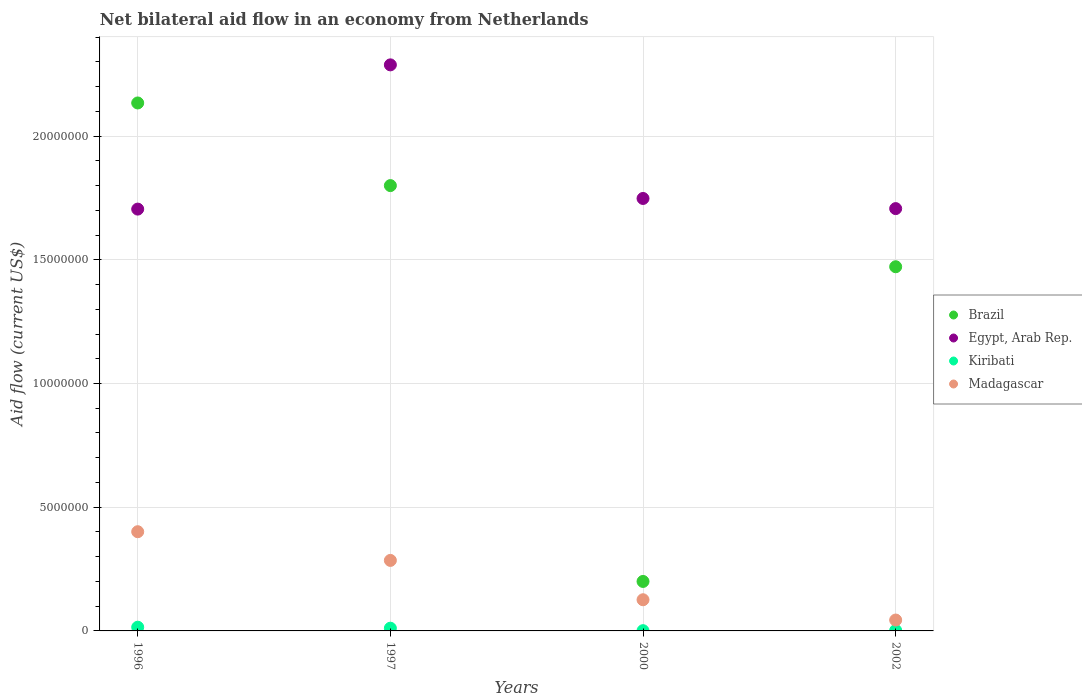How many different coloured dotlines are there?
Offer a terse response. 4. Is the number of dotlines equal to the number of legend labels?
Make the answer very short. Yes. What is the net bilateral aid flow in Madagascar in 1996?
Your response must be concise. 4.01e+06. Across all years, what is the minimum net bilateral aid flow in Egypt, Arab Rep.?
Give a very brief answer. 1.70e+07. In which year was the net bilateral aid flow in Kiribati maximum?
Your response must be concise. 1996. In which year was the net bilateral aid flow in Kiribati minimum?
Offer a very short reply. 2000. What is the total net bilateral aid flow in Egypt, Arab Rep. in the graph?
Give a very brief answer. 7.45e+07. What is the difference between the net bilateral aid flow in Brazil in 2000 and that in 2002?
Provide a short and direct response. -1.27e+07. What is the difference between the net bilateral aid flow in Egypt, Arab Rep. in 2002 and the net bilateral aid flow in Kiribati in 1997?
Offer a very short reply. 1.70e+07. What is the average net bilateral aid flow in Madagascar per year?
Your answer should be compact. 2.14e+06. In the year 1997, what is the difference between the net bilateral aid flow in Madagascar and net bilateral aid flow in Kiribati?
Provide a short and direct response. 2.74e+06. What is the ratio of the net bilateral aid flow in Madagascar in 1997 to that in 2000?
Give a very brief answer. 2.26. Is the net bilateral aid flow in Madagascar in 1996 less than that in 1997?
Provide a succinct answer. No. Is the difference between the net bilateral aid flow in Madagascar in 1997 and 2002 greater than the difference between the net bilateral aid flow in Kiribati in 1997 and 2002?
Provide a short and direct response. Yes. What is the difference between the highest and the second highest net bilateral aid flow in Egypt, Arab Rep.?
Provide a succinct answer. 5.40e+06. What is the difference between the highest and the lowest net bilateral aid flow in Brazil?
Provide a short and direct response. 1.93e+07. Is it the case that in every year, the sum of the net bilateral aid flow in Egypt, Arab Rep. and net bilateral aid flow in Brazil  is greater than the sum of net bilateral aid flow in Madagascar and net bilateral aid flow in Kiribati?
Keep it short and to the point. Yes. Is it the case that in every year, the sum of the net bilateral aid flow in Madagascar and net bilateral aid flow in Egypt, Arab Rep.  is greater than the net bilateral aid flow in Kiribati?
Your answer should be compact. Yes. Does the net bilateral aid flow in Brazil monotonically increase over the years?
Your answer should be compact. No. Is the net bilateral aid flow in Kiribati strictly greater than the net bilateral aid flow in Brazil over the years?
Provide a succinct answer. No. Is the net bilateral aid flow in Egypt, Arab Rep. strictly less than the net bilateral aid flow in Brazil over the years?
Ensure brevity in your answer.  No. What is the difference between two consecutive major ticks on the Y-axis?
Offer a very short reply. 5.00e+06. Does the graph contain grids?
Your answer should be compact. Yes. Where does the legend appear in the graph?
Your response must be concise. Center right. How many legend labels are there?
Ensure brevity in your answer.  4. What is the title of the graph?
Your response must be concise. Net bilateral aid flow in an economy from Netherlands. Does "Russian Federation" appear as one of the legend labels in the graph?
Ensure brevity in your answer.  No. What is the label or title of the Y-axis?
Your answer should be compact. Aid flow (current US$). What is the Aid flow (current US$) of Brazil in 1996?
Offer a very short reply. 2.13e+07. What is the Aid flow (current US$) in Egypt, Arab Rep. in 1996?
Your answer should be compact. 1.70e+07. What is the Aid flow (current US$) of Madagascar in 1996?
Give a very brief answer. 4.01e+06. What is the Aid flow (current US$) of Brazil in 1997?
Ensure brevity in your answer.  1.80e+07. What is the Aid flow (current US$) of Egypt, Arab Rep. in 1997?
Give a very brief answer. 2.29e+07. What is the Aid flow (current US$) in Kiribati in 1997?
Provide a short and direct response. 1.10e+05. What is the Aid flow (current US$) of Madagascar in 1997?
Your response must be concise. 2.85e+06. What is the Aid flow (current US$) in Brazil in 2000?
Offer a very short reply. 2.00e+06. What is the Aid flow (current US$) in Egypt, Arab Rep. in 2000?
Your answer should be compact. 1.75e+07. What is the Aid flow (current US$) of Kiribati in 2000?
Give a very brief answer. 10000. What is the Aid flow (current US$) of Madagascar in 2000?
Your response must be concise. 1.26e+06. What is the Aid flow (current US$) of Brazil in 2002?
Offer a very short reply. 1.47e+07. What is the Aid flow (current US$) in Egypt, Arab Rep. in 2002?
Offer a terse response. 1.71e+07. What is the Aid flow (current US$) in Kiribati in 2002?
Your answer should be very brief. 2.00e+04. What is the Aid flow (current US$) of Madagascar in 2002?
Your answer should be very brief. 4.40e+05. Across all years, what is the maximum Aid flow (current US$) of Brazil?
Your answer should be compact. 2.13e+07. Across all years, what is the maximum Aid flow (current US$) in Egypt, Arab Rep.?
Make the answer very short. 2.29e+07. Across all years, what is the maximum Aid flow (current US$) of Kiribati?
Ensure brevity in your answer.  1.50e+05. Across all years, what is the maximum Aid flow (current US$) of Madagascar?
Your answer should be compact. 4.01e+06. Across all years, what is the minimum Aid flow (current US$) of Brazil?
Keep it short and to the point. 2.00e+06. Across all years, what is the minimum Aid flow (current US$) of Egypt, Arab Rep.?
Provide a short and direct response. 1.70e+07. Across all years, what is the minimum Aid flow (current US$) of Madagascar?
Ensure brevity in your answer.  4.40e+05. What is the total Aid flow (current US$) in Brazil in the graph?
Your answer should be very brief. 5.61e+07. What is the total Aid flow (current US$) in Egypt, Arab Rep. in the graph?
Offer a very short reply. 7.45e+07. What is the total Aid flow (current US$) of Kiribati in the graph?
Provide a short and direct response. 2.90e+05. What is the total Aid flow (current US$) of Madagascar in the graph?
Your answer should be compact. 8.56e+06. What is the difference between the Aid flow (current US$) of Brazil in 1996 and that in 1997?
Keep it short and to the point. 3.34e+06. What is the difference between the Aid flow (current US$) in Egypt, Arab Rep. in 1996 and that in 1997?
Keep it short and to the point. -5.83e+06. What is the difference between the Aid flow (current US$) of Kiribati in 1996 and that in 1997?
Your response must be concise. 4.00e+04. What is the difference between the Aid flow (current US$) in Madagascar in 1996 and that in 1997?
Provide a short and direct response. 1.16e+06. What is the difference between the Aid flow (current US$) of Brazil in 1996 and that in 2000?
Your answer should be very brief. 1.93e+07. What is the difference between the Aid flow (current US$) in Egypt, Arab Rep. in 1996 and that in 2000?
Provide a succinct answer. -4.30e+05. What is the difference between the Aid flow (current US$) in Madagascar in 1996 and that in 2000?
Your response must be concise. 2.75e+06. What is the difference between the Aid flow (current US$) in Brazil in 1996 and that in 2002?
Your response must be concise. 6.62e+06. What is the difference between the Aid flow (current US$) in Egypt, Arab Rep. in 1996 and that in 2002?
Provide a short and direct response. -2.00e+04. What is the difference between the Aid flow (current US$) of Madagascar in 1996 and that in 2002?
Keep it short and to the point. 3.57e+06. What is the difference between the Aid flow (current US$) in Brazil in 1997 and that in 2000?
Give a very brief answer. 1.60e+07. What is the difference between the Aid flow (current US$) of Egypt, Arab Rep. in 1997 and that in 2000?
Provide a short and direct response. 5.40e+06. What is the difference between the Aid flow (current US$) of Madagascar in 1997 and that in 2000?
Your answer should be compact. 1.59e+06. What is the difference between the Aid flow (current US$) in Brazil in 1997 and that in 2002?
Give a very brief answer. 3.28e+06. What is the difference between the Aid flow (current US$) in Egypt, Arab Rep. in 1997 and that in 2002?
Offer a very short reply. 5.81e+06. What is the difference between the Aid flow (current US$) of Madagascar in 1997 and that in 2002?
Ensure brevity in your answer.  2.41e+06. What is the difference between the Aid flow (current US$) of Brazil in 2000 and that in 2002?
Ensure brevity in your answer.  -1.27e+07. What is the difference between the Aid flow (current US$) in Egypt, Arab Rep. in 2000 and that in 2002?
Keep it short and to the point. 4.10e+05. What is the difference between the Aid flow (current US$) of Kiribati in 2000 and that in 2002?
Keep it short and to the point. -10000. What is the difference between the Aid flow (current US$) in Madagascar in 2000 and that in 2002?
Give a very brief answer. 8.20e+05. What is the difference between the Aid flow (current US$) in Brazil in 1996 and the Aid flow (current US$) in Egypt, Arab Rep. in 1997?
Provide a succinct answer. -1.54e+06. What is the difference between the Aid flow (current US$) of Brazil in 1996 and the Aid flow (current US$) of Kiribati in 1997?
Offer a terse response. 2.12e+07. What is the difference between the Aid flow (current US$) of Brazil in 1996 and the Aid flow (current US$) of Madagascar in 1997?
Offer a terse response. 1.85e+07. What is the difference between the Aid flow (current US$) of Egypt, Arab Rep. in 1996 and the Aid flow (current US$) of Kiribati in 1997?
Offer a very short reply. 1.69e+07. What is the difference between the Aid flow (current US$) of Egypt, Arab Rep. in 1996 and the Aid flow (current US$) of Madagascar in 1997?
Ensure brevity in your answer.  1.42e+07. What is the difference between the Aid flow (current US$) of Kiribati in 1996 and the Aid flow (current US$) of Madagascar in 1997?
Your response must be concise. -2.70e+06. What is the difference between the Aid flow (current US$) of Brazil in 1996 and the Aid flow (current US$) of Egypt, Arab Rep. in 2000?
Your response must be concise. 3.86e+06. What is the difference between the Aid flow (current US$) of Brazil in 1996 and the Aid flow (current US$) of Kiribati in 2000?
Your answer should be very brief. 2.13e+07. What is the difference between the Aid flow (current US$) of Brazil in 1996 and the Aid flow (current US$) of Madagascar in 2000?
Give a very brief answer. 2.01e+07. What is the difference between the Aid flow (current US$) in Egypt, Arab Rep. in 1996 and the Aid flow (current US$) in Kiribati in 2000?
Your answer should be very brief. 1.70e+07. What is the difference between the Aid flow (current US$) of Egypt, Arab Rep. in 1996 and the Aid flow (current US$) of Madagascar in 2000?
Your response must be concise. 1.58e+07. What is the difference between the Aid flow (current US$) in Kiribati in 1996 and the Aid flow (current US$) in Madagascar in 2000?
Make the answer very short. -1.11e+06. What is the difference between the Aid flow (current US$) of Brazil in 1996 and the Aid flow (current US$) of Egypt, Arab Rep. in 2002?
Keep it short and to the point. 4.27e+06. What is the difference between the Aid flow (current US$) in Brazil in 1996 and the Aid flow (current US$) in Kiribati in 2002?
Ensure brevity in your answer.  2.13e+07. What is the difference between the Aid flow (current US$) of Brazil in 1996 and the Aid flow (current US$) of Madagascar in 2002?
Give a very brief answer. 2.09e+07. What is the difference between the Aid flow (current US$) in Egypt, Arab Rep. in 1996 and the Aid flow (current US$) in Kiribati in 2002?
Offer a very short reply. 1.70e+07. What is the difference between the Aid flow (current US$) in Egypt, Arab Rep. in 1996 and the Aid flow (current US$) in Madagascar in 2002?
Keep it short and to the point. 1.66e+07. What is the difference between the Aid flow (current US$) of Kiribati in 1996 and the Aid flow (current US$) of Madagascar in 2002?
Provide a short and direct response. -2.90e+05. What is the difference between the Aid flow (current US$) of Brazil in 1997 and the Aid flow (current US$) of Egypt, Arab Rep. in 2000?
Give a very brief answer. 5.20e+05. What is the difference between the Aid flow (current US$) of Brazil in 1997 and the Aid flow (current US$) of Kiribati in 2000?
Your response must be concise. 1.80e+07. What is the difference between the Aid flow (current US$) in Brazil in 1997 and the Aid flow (current US$) in Madagascar in 2000?
Your response must be concise. 1.67e+07. What is the difference between the Aid flow (current US$) of Egypt, Arab Rep. in 1997 and the Aid flow (current US$) of Kiribati in 2000?
Keep it short and to the point. 2.29e+07. What is the difference between the Aid flow (current US$) of Egypt, Arab Rep. in 1997 and the Aid flow (current US$) of Madagascar in 2000?
Offer a terse response. 2.16e+07. What is the difference between the Aid flow (current US$) of Kiribati in 1997 and the Aid flow (current US$) of Madagascar in 2000?
Ensure brevity in your answer.  -1.15e+06. What is the difference between the Aid flow (current US$) in Brazil in 1997 and the Aid flow (current US$) in Egypt, Arab Rep. in 2002?
Keep it short and to the point. 9.30e+05. What is the difference between the Aid flow (current US$) in Brazil in 1997 and the Aid flow (current US$) in Kiribati in 2002?
Offer a very short reply. 1.80e+07. What is the difference between the Aid flow (current US$) of Brazil in 1997 and the Aid flow (current US$) of Madagascar in 2002?
Ensure brevity in your answer.  1.76e+07. What is the difference between the Aid flow (current US$) of Egypt, Arab Rep. in 1997 and the Aid flow (current US$) of Kiribati in 2002?
Your answer should be very brief. 2.29e+07. What is the difference between the Aid flow (current US$) in Egypt, Arab Rep. in 1997 and the Aid flow (current US$) in Madagascar in 2002?
Your answer should be very brief. 2.24e+07. What is the difference between the Aid flow (current US$) in Kiribati in 1997 and the Aid flow (current US$) in Madagascar in 2002?
Your answer should be very brief. -3.30e+05. What is the difference between the Aid flow (current US$) in Brazil in 2000 and the Aid flow (current US$) in Egypt, Arab Rep. in 2002?
Provide a succinct answer. -1.51e+07. What is the difference between the Aid flow (current US$) of Brazil in 2000 and the Aid flow (current US$) of Kiribati in 2002?
Your response must be concise. 1.98e+06. What is the difference between the Aid flow (current US$) in Brazil in 2000 and the Aid flow (current US$) in Madagascar in 2002?
Your answer should be very brief. 1.56e+06. What is the difference between the Aid flow (current US$) of Egypt, Arab Rep. in 2000 and the Aid flow (current US$) of Kiribati in 2002?
Offer a very short reply. 1.75e+07. What is the difference between the Aid flow (current US$) of Egypt, Arab Rep. in 2000 and the Aid flow (current US$) of Madagascar in 2002?
Your response must be concise. 1.70e+07. What is the difference between the Aid flow (current US$) of Kiribati in 2000 and the Aid flow (current US$) of Madagascar in 2002?
Your response must be concise. -4.30e+05. What is the average Aid flow (current US$) of Brazil per year?
Your response must be concise. 1.40e+07. What is the average Aid flow (current US$) in Egypt, Arab Rep. per year?
Ensure brevity in your answer.  1.86e+07. What is the average Aid flow (current US$) of Kiribati per year?
Give a very brief answer. 7.25e+04. What is the average Aid flow (current US$) of Madagascar per year?
Offer a terse response. 2.14e+06. In the year 1996, what is the difference between the Aid flow (current US$) of Brazil and Aid flow (current US$) of Egypt, Arab Rep.?
Your answer should be very brief. 4.29e+06. In the year 1996, what is the difference between the Aid flow (current US$) of Brazil and Aid flow (current US$) of Kiribati?
Make the answer very short. 2.12e+07. In the year 1996, what is the difference between the Aid flow (current US$) of Brazil and Aid flow (current US$) of Madagascar?
Keep it short and to the point. 1.73e+07. In the year 1996, what is the difference between the Aid flow (current US$) of Egypt, Arab Rep. and Aid flow (current US$) of Kiribati?
Your answer should be very brief. 1.69e+07. In the year 1996, what is the difference between the Aid flow (current US$) in Egypt, Arab Rep. and Aid flow (current US$) in Madagascar?
Ensure brevity in your answer.  1.30e+07. In the year 1996, what is the difference between the Aid flow (current US$) of Kiribati and Aid flow (current US$) of Madagascar?
Keep it short and to the point. -3.86e+06. In the year 1997, what is the difference between the Aid flow (current US$) of Brazil and Aid flow (current US$) of Egypt, Arab Rep.?
Offer a very short reply. -4.88e+06. In the year 1997, what is the difference between the Aid flow (current US$) of Brazil and Aid flow (current US$) of Kiribati?
Your answer should be very brief. 1.79e+07. In the year 1997, what is the difference between the Aid flow (current US$) of Brazil and Aid flow (current US$) of Madagascar?
Make the answer very short. 1.52e+07. In the year 1997, what is the difference between the Aid flow (current US$) of Egypt, Arab Rep. and Aid flow (current US$) of Kiribati?
Provide a short and direct response. 2.28e+07. In the year 1997, what is the difference between the Aid flow (current US$) of Egypt, Arab Rep. and Aid flow (current US$) of Madagascar?
Your answer should be very brief. 2.00e+07. In the year 1997, what is the difference between the Aid flow (current US$) in Kiribati and Aid flow (current US$) in Madagascar?
Give a very brief answer. -2.74e+06. In the year 2000, what is the difference between the Aid flow (current US$) in Brazil and Aid flow (current US$) in Egypt, Arab Rep.?
Your answer should be compact. -1.55e+07. In the year 2000, what is the difference between the Aid flow (current US$) of Brazil and Aid flow (current US$) of Kiribati?
Ensure brevity in your answer.  1.99e+06. In the year 2000, what is the difference between the Aid flow (current US$) in Brazil and Aid flow (current US$) in Madagascar?
Keep it short and to the point. 7.40e+05. In the year 2000, what is the difference between the Aid flow (current US$) of Egypt, Arab Rep. and Aid flow (current US$) of Kiribati?
Ensure brevity in your answer.  1.75e+07. In the year 2000, what is the difference between the Aid flow (current US$) of Egypt, Arab Rep. and Aid flow (current US$) of Madagascar?
Provide a succinct answer. 1.62e+07. In the year 2000, what is the difference between the Aid flow (current US$) in Kiribati and Aid flow (current US$) in Madagascar?
Ensure brevity in your answer.  -1.25e+06. In the year 2002, what is the difference between the Aid flow (current US$) in Brazil and Aid flow (current US$) in Egypt, Arab Rep.?
Give a very brief answer. -2.35e+06. In the year 2002, what is the difference between the Aid flow (current US$) in Brazil and Aid flow (current US$) in Kiribati?
Your answer should be very brief. 1.47e+07. In the year 2002, what is the difference between the Aid flow (current US$) in Brazil and Aid flow (current US$) in Madagascar?
Offer a very short reply. 1.43e+07. In the year 2002, what is the difference between the Aid flow (current US$) in Egypt, Arab Rep. and Aid flow (current US$) in Kiribati?
Offer a terse response. 1.70e+07. In the year 2002, what is the difference between the Aid flow (current US$) of Egypt, Arab Rep. and Aid flow (current US$) of Madagascar?
Ensure brevity in your answer.  1.66e+07. In the year 2002, what is the difference between the Aid flow (current US$) of Kiribati and Aid flow (current US$) of Madagascar?
Your response must be concise. -4.20e+05. What is the ratio of the Aid flow (current US$) in Brazil in 1996 to that in 1997?
Offer a very short reply. 1.19. What is the ratio of the Aid flow (current US$) of Egypt, Arab Rep. in 1996 to that in 1997?
Your response must be concise. 0.75. What is the ratio of the Aid flow (current US$) in Kiribati in 1996 to that in 1997?
Provide a succinct answer. 1.36. What is the ratio of the Aid flow (current US$) in Madagascar in 1996 to that in 1997?
Ensure brevity in your answer.  1.41. What is the ratio of the Aid flow (current US$) of Brazil in 1996 to that in 2000?
Offer a terse response. 10.67. What is the ratio of the Aid flow (current US$) of Egypt, Arab Rep. in 1996 to that in 2000?
Your response must be concise. 0.98. What is the ratio of the Aid flow (current US$) in Kiribati in 1996 to that in 2000?
Make the answer very short. 15. What is the ratio of the Aid flow (current US$) in Madagascar in 1996 to that in 2000?
Your answer should be very brief. 3.18. What is the ratio of the Aid flow (current US$) in Brazil in 1996 to that in 2002?
Make the answer very short. 1.45. What is the ratio of the Aid flow (current US$) of Egypt, Arab Rep. in 1996 to that in 2002?
Ensure brevity in your answer.  1. What is the ratio of the Aid flow (current US$) in Kiribati in 1996 to that in 2002?
Your answer should be compact. 7.5. What is the ratio of the Aid flow (current US$) in Madagascar in 1996 to that in 2002?
Make the answer very short. 9.11. What is the ratio of the Aid flow (current US$) in Egypt, Arab Rep. in 1997 to that in 2000?
Your response must be concise. 1.31. What is the ratio of the Aid flow (current US$) of Kiribati in 1997 to that in 2000?
Offer a very short reply. 11. What is the ratio of the Aid flow (current US$) of Madagascar in 1997 to that in 2000?
Provide a succinct answer. 2.26. What is the ratio of the Aid flow (current US$) of Brazil in 1997 to that in 2002?
Your answer should be compact. 1.22. What is the ratio of the Aid flow (current US$) of Egypt, Arab Rep. in 1997 to that in 2002?
Ensure brevity in your answer.  1.34. What is the ratio of the Aid flow (current US$) in Madagascar in 1997 to that in 2002?
Provide a short and direct response. 6.48. What is the ratio of the Aid flow (current US$) in Brazil in 2000 to that in 2002?
Give a very brief answer. 0.14. What is the ratio of the Aid flow (current US$) in Egypt, Arab Rep. in 2000 to that in 2002?
Your answer should be very brief. 1.02. What is the ratio of the Aid flow (current US$) in Kiribati in 2000 to that in 2002?
Provide a succinct answer. 0.5. What is the ratio of the Aid flow (current US$) of Madagascar in 2000 to that in 2002?
Give a very brief answer. 2.86. What is the difference between the highest and the second highest Aid flow (current US$) in Brazil?
Your response must be concise. 3.34e+06. What is the difference between the highest and the second highest Aid flow (current US$) in Egypt, Arab Rep.?
Your response must be concise. 5.40e+06. What is the difference between the highest and the second highest Aid flow (current US$) in Kiribati?
Your answer should be very brief. 4.00e+04. What is the difference between the highest and the second highest Aid flow (current US$) in Madagascar?
Provide a succinct answer. 1.16e+06. What is the difference between the highest and the lowest Aid flow (current US$) in Brazil?
Make the answer very short. 1.93e+07. What is the difference between the highest and the lowest Aid flow (current US$) of Egypt, Arab Rep.?
Provide a short and direct response. 5.83e+06. What is the difference between the highest and the lowest Aid flow (current US$) of Madagascar?
Your response must be concise. 3.57e+06. 